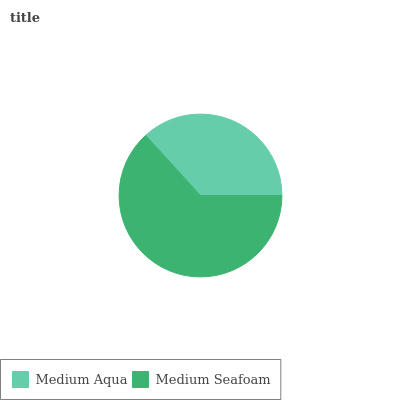Is Medium Aqua the minimum?
Answer yes or no. Yes. Is Medium Seafoam the maximum?
Answer yes or no. Yes. Is Medium Seafoam the minimum?
Answer yes or no. No. Is Medium Seafoam greater than Medium Aqua?
Answer yes or no. Yes. Is Medium Aqua less than Medium Seafoam?
Answer yes or no. Yes. Is Medium Aqua greater than Medium Seafoam?
Answer yes or no. No. Is Medium Seafoam less than Medium Aqua?
Answer yes or no. No. Is Medium Seafoam the high median?
Answer yes or no. Yes. Is Medium Aqua the low median?
Answer yes or no. Yes. Is Medium Aqua the high median?
Answer yes or no. No. Is Medium Seafoam the low median?
Answer yes or no. No. 